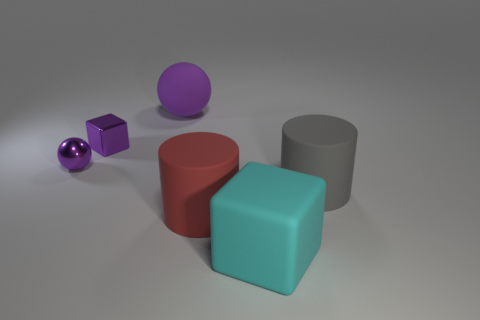Add 3 cyan rubber blocks. How many objects exist? 9 Subtract all balls. How many objects are left? 4 Subtract all large rubber cubes. Subtract all blue spheres. How many objects are left? 5 Add 1 purple metal things. How many purple metal things are left? 3 Add 1 cyan matte things. How many cyan matte things exist? 2 Subtract 0 gray cubes. How many objects are left? 6 